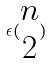<formula> <loc_0><loc_0><loc_500><loc_500>\epsilon ( \begin{matrix} n \\ 2 \end{matrix} )</formula> 